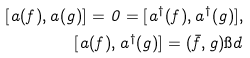<formula> <loc_0><loc_0><loc_500><loc_500>[ a ( f ) , a ( g ) ] = 0 = [ a ^ { \dagger } ( f ) , a ^ { \dagger } ( g ) ] , \\ [ a ( f ) , a ^ { \dagger } ( g ) ] = ( \bar { f } , g ) \i d</formula> 